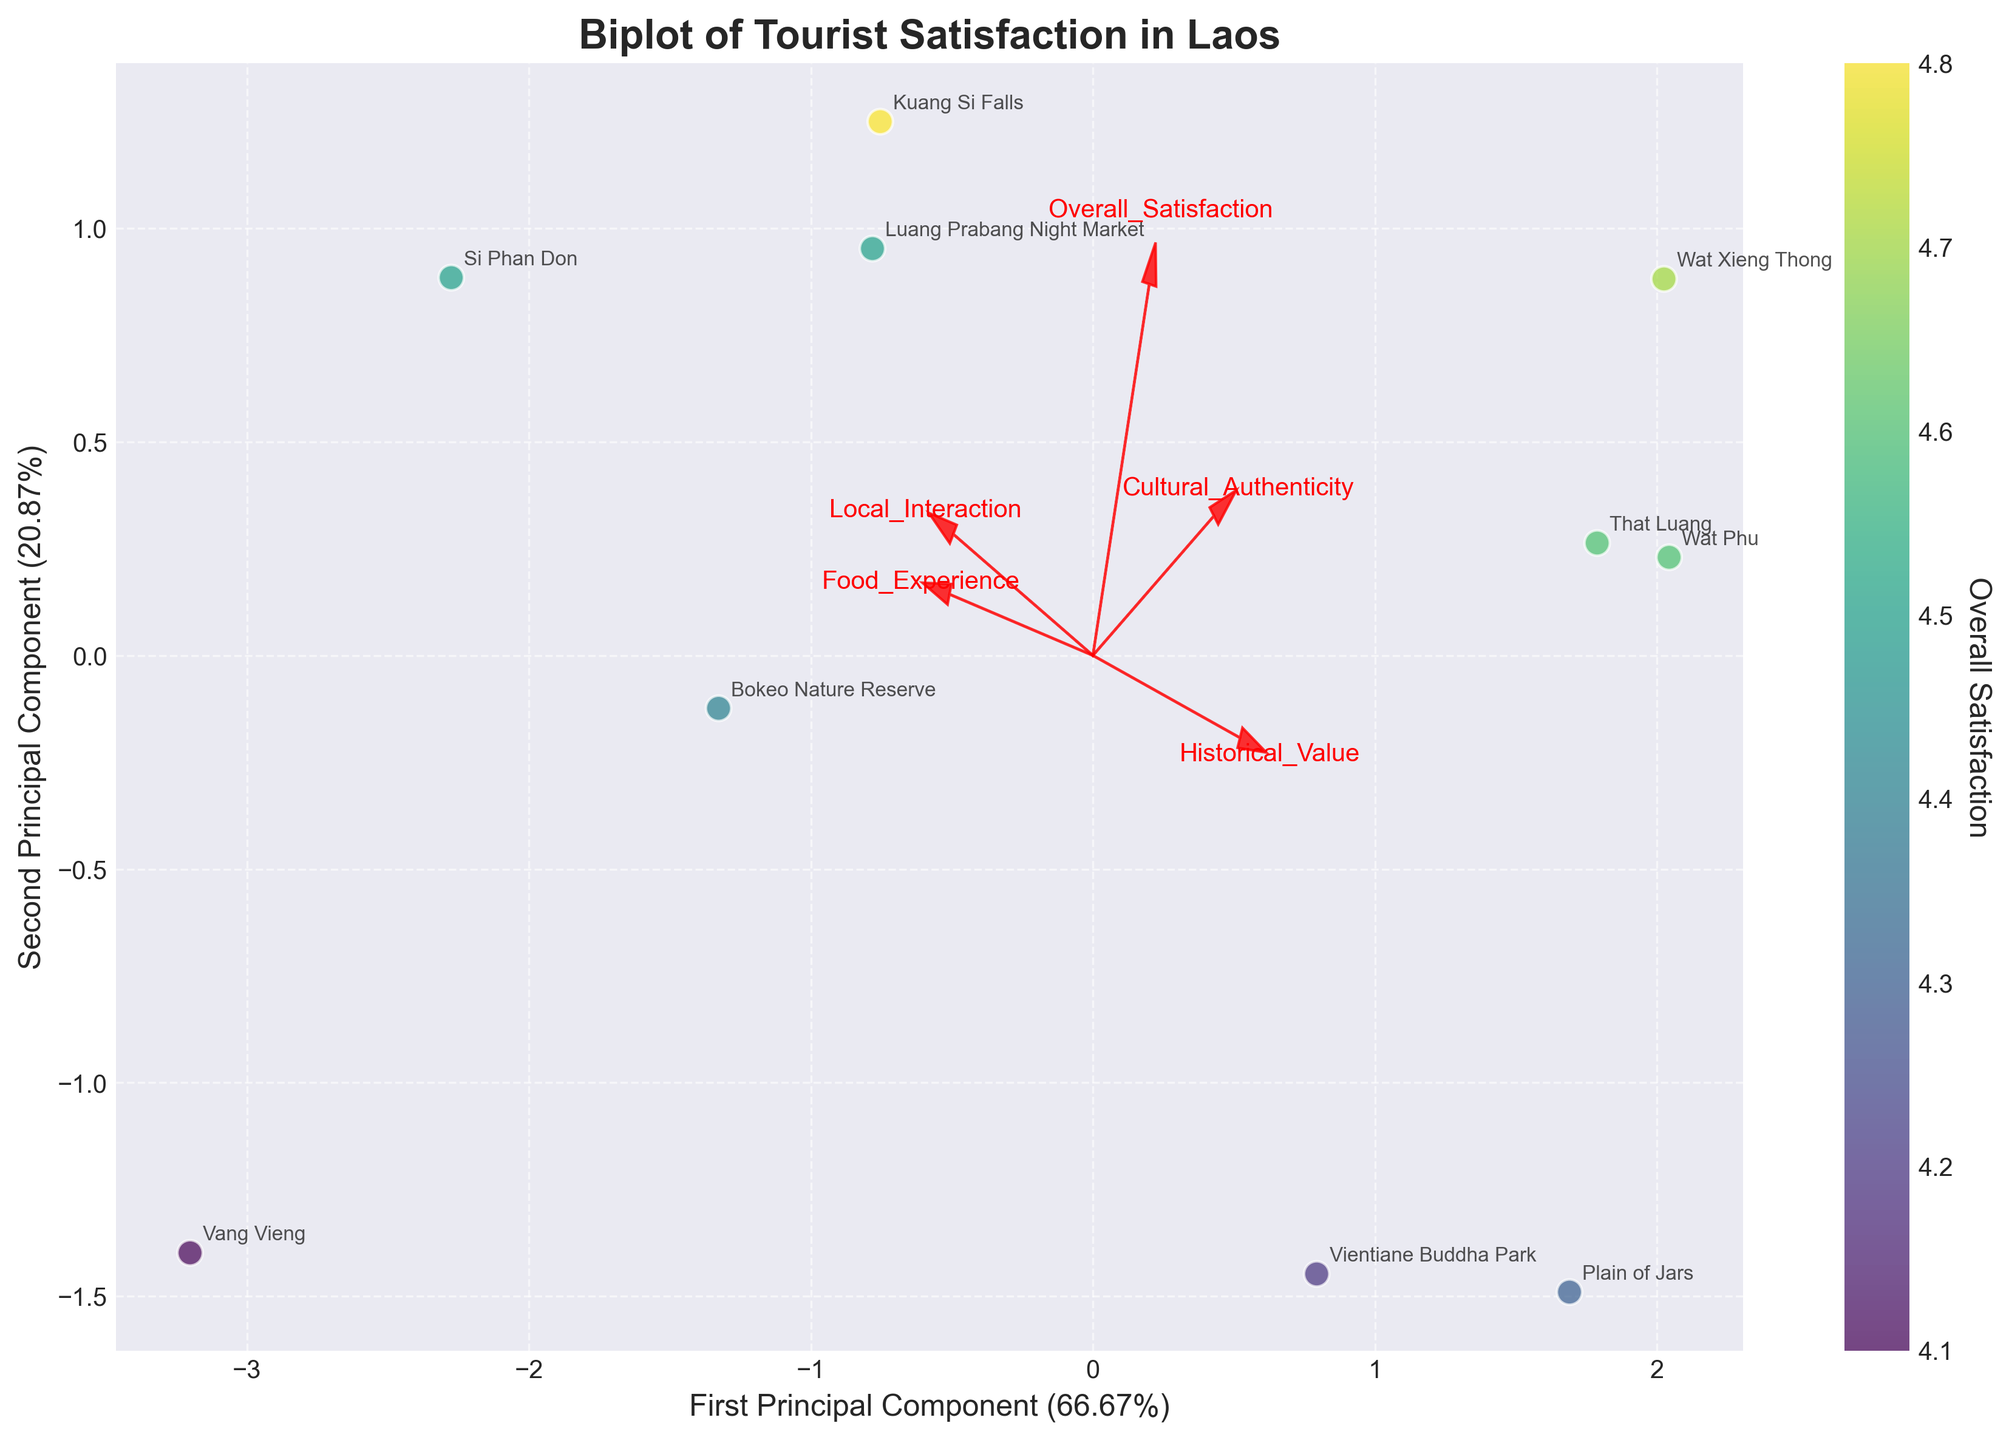Which tourist site has the highest overall satisfaction rating? Look for the point with the strongest color on the colorbar which represents high overall satisfaction, and check its label.
Answer: Kuang Si Falls What is the title of the biplot? Locate the title text at the top center of the chart.
Answer: Biplot of Tourist Satisfaction in Laos Which feature vector has the longest arrow in the positive x-direction? Identify the arrow extending furthest to the right along the x-axis, marked in red with the feature name.
Answer: Cultural Authenticity How many principal components are shown in the biplot? Count the number of axes labelled with principal component names described on the axes labels.
Answer: 2 Which aspect of Laotian culture contributes most negatively to the second principal component? Find the red arrow that points most downwards (negative y-direction).
Answer: Historical Value What percentage of variance is explained by the first principal component? Check the percentage value given at the x-axis label.
Answer: ~43.5% Between Luang Prabang Night Market and Vang Vieng, which tourist site has a higher overall satisfaction rating? Compare the colors of the points representing Luang Prabang Night Market and Vang Vieng on the colorbar scale.
Answer: Luang Prabang Night Market What are the top three features contributing to the first principal component? Identify the red arrows pointing strongly in the x-direction and read their labels.
Answer: Cultural Authenticity, Overall Satisfaction, Local Interaction Which feature vector is nearly equally associated with both principal components? Look for the red arrow that equally points between x and y directions.
Answer: Food Experience Are there any tourist sites located near the origin (0,0) of the biplot? Observe the points closest to the center of the plot, interpret their minimal principal component values, and check their labels.
Answer: No 